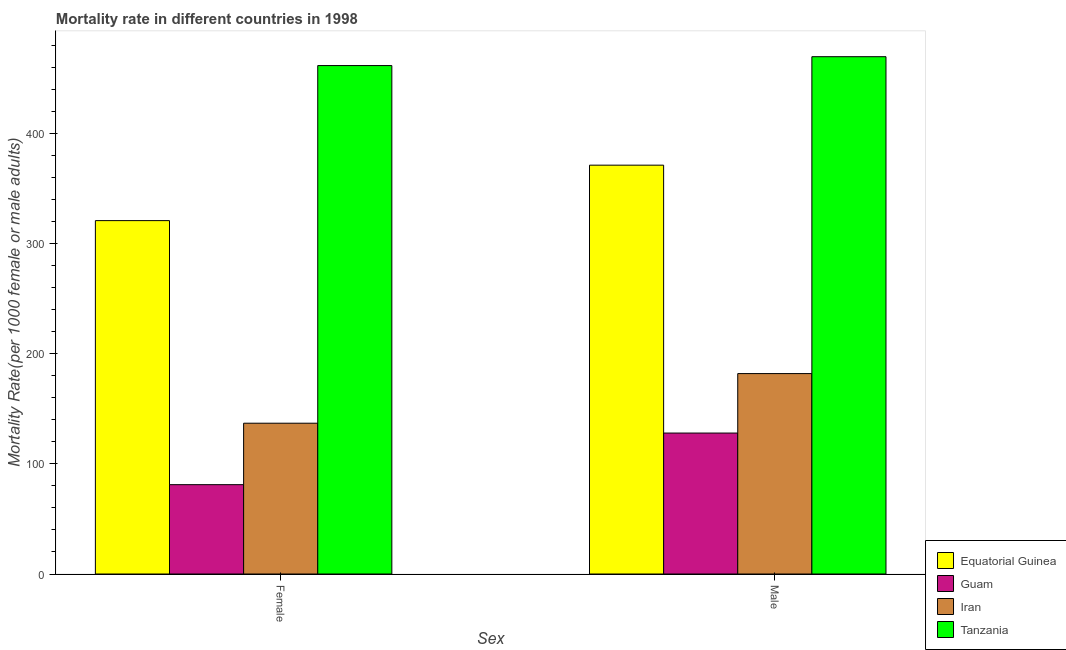How many different coloured bars are there?
Ensure brevity in your answer.  4. Are the number of bars on each tick of the X-axis equal?
Your answer should be very brief. Yes. How many bars are there on the 1st tick from the left?
Your response must be concise. 4. What is the label of the 2nd group of bars from the left?
Offer a terse response. Male. What is the female mortality rate in Guam?
Offer a very short reply. 81.09. Across all countries, what is the maximum male mortality rate?
Offer a terse response. 469.56. Across all countries, what is the minimum female mortality rate?
Provide a succinct answer. 81.09. In which country was the female mortality rate maximum?
Give a very brief answer. Tanzania. In which country was the male mortality rate minimum?
Your answer should be compact. Guam. What is the total female mortality rate in the graph?
Ensure brevity in your answer.  1000.23. What is the difference between the male mortality rate in Tanzania and that in Iran?
Your response must be concise. 287.64. What is the difference between the male mortality rate in Iran and the female mortality rate in Equatorial Guinea?
Keep it short and to the point. -138.85. What is the average male mortality rate per country?
Provide a short and direct response. 287.63. What is the difference between the male mortality rate and female mortality rate in Tanzania?
Keep it short and to the point. 8.06. What is the ratio of the male mortality rate in Tanzania to that in Equatorial Guinea?
Ensure brevity in your answer.  1.27. In how many countries, is the female mortality rate greater than the average female mortality rate taken over all countries?
Your answer should be compact. 2. What does the 3rd bar from the left in Male represents?
Your answer should be compact. Iran. What does the 4th bar from the right in Male represents?
Your answer should be very brief. Equatorial Guinea. Are all the bars in the graph horizontal?
Provide a succinct answer. No. What is the difference between two consecutive major ticks on the Y-axis?
Ensure brevity in your answer.  100. Are the values on the major ticks of Y-axis written in scientific E-notation?
Your response must be concise. No. Does the graph contain any zero values?
Provide a short and direct response. No. How are the legend labels stacked?
Provide a short and direct response. Vertical. What is the title of the graph?
Your response must be concise. Mortality rate in different countries in 1998. What is the label or title of the X-axis?
Your response must be concise. Sex. What is the label or title of the Y-axis?
Provide a succinct answer. Mortality Rate(per 1000 female or male adults). What is the Mortality Rate(per 1000 female or male adults) of Equatorial Guinea in Female?
Offer a very short reply. 320.77. What is the Mortality Rate(per 1000 female or male adults) of Guam in Female?
Keep it short and to the point. 81.09. What is the Mortality Rate(per 1000 female or male adults) in Iran in Female?
Offer a terse response. 136.87. What is the Mortality Rate(per 1000 female or male adults) of Tanzania in Female?
Make the answer very short. 461.5. What is the Mortality Rate(per 1000 female or male adults) of Equatorial Guinea in Male?
Give a very brief answer. 371.1. What is the Mortality Rate(per 1000 female or male adults) in Guam in Male?
Your answer should be compact. 127.93. What is the Mortality Rate(per 1000 female or male adults) of Iran in Male?
Make the answer very short. 181.92. What is the Mortality Rate(per 1000 female or male adults) of Tanzania in Male?
Offer a very short reply. 469.56. Across all Sex, what is the maximum Mortality Rate(per 1000 female or male adults) in Equatorial Guinea?
Make the answer very short. 371.1. Across all Sex, what is the maximum Mortality Rate(per 1000 female or male adults) of Guam?
Give a very brief answer. 127.93. Across all Sex, what is the maximum Mortality Rate(per 1000 female or male adults) in Iran?
Provide a short and direct response. 181.92. Across all Sex, what is the maximum Mortality Rate(per 1000 female or male adults) in Tanzania?
Provide a succinct answer. 469.56. Across all Sex, what is the minimum Mortality Rate(per 1000 female or male adults) of Equatorial Guinea?
Keep it short and to the point. 320.77. Across all Sex, what is the minimum Mortality Rate(per 1000 female or male adults) in Guam?
Your response must be concise. 81.09. Across all Sex, what is the minimum Mortality Rate(per 1000 female or male adults) in Iran?
Offer a very short reply. 136.87. Across all Sex, what is the minimum Mortality Rate(per 1000 female or male adults) of Tanzania?
Offer a very short reply. 461.5. What is the total Mortality Rate(per 1000 female or male adults) in Equatorial Guinea in the graph?
Offer a terse response. 691.87. What is the total Mortality Rate(per 1000 female or male adults) in Guam in the graph?
Offer a terse response. 209.02. What is the total Mortality Rate(per 1000 female or male adults) in Iran in the graph?
Your answer should be very brief. 318.79. What is the total Mortality Rate(per 1000 female or male adults) of Tanzania in the graph?
Give a very brief answer. 931.06. What is the difference between the Mortality Rate(per 1000 female or male adults) in Equatorial Guinea in Female and that in Male?
Give a very brief answer. -50.33. What is the difference between the Mortality Rate(per 1000 female or male adults) in Guam in Female and that in Male?
Make the answer very short. -46.84. What is the difference between the Mortality Rate(per 1000 female or male adults) of Iran in Female and that in Male?
Your answer should be compact. -45.05. What is the difference between the Mortality Rate(per 1000 female or male adults) of Tanzania in Female and that in Male?
Keep it short and to the point. -8.06. What is the difference between the Mortality Rate(per 1000 female or male adults) of Equatorial Guinea in Female and the Mortality Rate(per 1000 female or male adults) of Guam in Male?
Make the answer very short. 192.84. What is the difference between the Mortality Rate(per 1000 female or male adults) of Equatorial Guinea in Female and the Mortality Rate(per 1000 female or male adults) of Iran in Male?
Your answer should be very brief. 138.85. What is the difference between the Mortality Rate(per 1000 female or male adults) of Equatorial Guinea in Female and the Mortality Rate(per 1000 female or male adults) of Tanzania in Male?
Your answer should be very brief. -148.79. What is the difference between the Mortality Rate(per 1000 female or male adults) in Guam in Female and the Mortality Rate(per 1000 female or male adults) in Iran in Male?
Provide a succinct answer. -100.83. What is the difference between the Mortality Rate(per 1000 female or male adults) in Guam in Female and the Mortality Rate(per 1000 female or male adults) in Tanzania in Male?
Provide a succinct answer. -388.47. What is the difference between the Mortality Rate(per 1000 female or male adults) in Iran in Female and the Mortality Rate(per 1000 female or male adults) in Tanzania in Male?
Ensure brevity in your answer.  -332.69. What is the average Mortality Rate(per 1000 female or male adults) in Equatorial Guinea per Sex?
Provide a succinct answer. 345.94. What is the average Mortality Rate(per 1000 female or male adults) in Guam per Sex?
Ensure brevity in your answer.  104.51. What is the average Mortality Rate(per 1000 female or male adults) in Iran per Sex?
Your answer should be very brief. 159.4. What is the average Mortality Rate(per 1000 female or male adults) in Tanzania per Sex?
Make the answer very short. 465.53. What is the difference between the Mortality Rate(per 1000 female or male adults) in Equatorial Guinea and Mortality Rate(per 1000 female or male adults) in Guam in Female?
Your answer should be compact. 239.68. What is the difference between the Mortality Rate(per 1000 female or male adults) of Equatorial Guinea and Mortality Rate(per 1000 female or male adults) of Iran in Female?
Your answer should be compact. 183.9. What is the difference between the Mortality Rate(per 1000 female or male adults) of Equatorial Guinea and Mortality Rate(per 1000 female or male adults) of Tanzania in Female?
Your answer should be very brief. -140.73. What is the difference between the Mortality Rate(per 1000 female or male adults) of Guam and Mortality Rate(per 1000 female or male adults) of Iran in Female?
Your answer should be very brief. -55.78. What is the difference between the Mortality Rate(per 1000 female or male adults) in Guam and Mortality Rate(per 1000 female or male adults) in Tanzania in Female?
Offer a very short reply. -380.41. What is the difference between the Mortality Rate(per 1000 female or male adults) of Iran and Mortality Rate(per 1000 female or male adults) of Tanzania in Female?
Provide a short and direct response. -324.63. What is the difference between the Mortality Rate(per 1000 female or male adults) of Equatorial Guinea and Mortality Rate(per 1000 female or male adults) of Guam in Male?
Make the answer very short. 243.17. What is the difference between the Mortality Rate(per 1000 female or male adults) of Equatorial Guinea and Mortality Rate(per 1000 female or male adults) of Iran in Male?
Give a very brief answer. 189.18. What is the difference between the Mortality Rate(per 1000 female or male adults) of Equatorial Guinea and Mortality Rate(per 1000 female or male adults) of Tanzania in Male?
Your answer should be very brief. -98.46. What is the difference between the Mortality Rate(per 1000 female or male adults) of Guam and Mortality Rate(per 1000 female or male adults) of Iran in Male?
Provide a succinct answer. -53.99. What is the difference between the Mortality Rate(per 1000 female or male adults) of Guam and Mortality Rate(per 1000 female or male adults) of Tanzania in Male?
Provide a short and direct response. -341.63. What is the difference between the Mortality Rate(per 1000 female or male adults) of Iran and Mortality Rate(per 1000 female or male adults) of Tanzania in Male?
Offer a very short reply. -287.64. What is the ratio of the Mortality Rate(per 1000 female or male adults) in Equatorial Guinea in Female to that in Male?
Ensure brevity in your answer.  0.86. What is the ratio of the Mortality Rate(per 1000 female or male adults) in Guam in Female to that in Male?
Offer a terse response. 0.63. What is the ratio of the Mortality Rate(per 1000 female or male adults) of Iran in Female to that in Male?
Your answer should be very brief. 0.75. What is the ratio of the Mortality Rate(per 1000 female or male adults) in Tanzania in Female to that in Male?
Your answer should be very brief. 0.98. What is the difference between the highest and the second highest Mortality Rate(per 1000 female or male adults) of Equatorial Guinea?
Your response must be concise. 50.33. What is the difference between the highest and the second highest Mortality Rate(per 1000 female or male adults) of Guam?
Provide a succinct answer. 46.84. What is the difference between the highest and the second highest Mortality Rate(per 1000 female or male adults) in Iran?
Give a very brief answer. 45.05. What is the difference between the highest and the second highest Mortality Rate(per 1000 female or male adults) in Tanzania?
Make the answer very short. 8.06. What is the difference between the highest and the lowest Mortality Rate(per 1000 female or male adults) of Equatorial Guinea?
Your answer should be compact. 50.33. What is the difference between the highest and the lowest Mortality Rate(per 1000 female or male adults) in Guam?
Offer a very short reply. 46.84. What is the difference between the highest and the lowest Mortality Rate(per 1000 female or male adults) in Iran?
Make the answer very short. 45.05. What is the difference between the highest and the lowest Mortality Rate(per 1000 female or male adults) of Tanzania?
Provide a short and direct response. 8.06. 